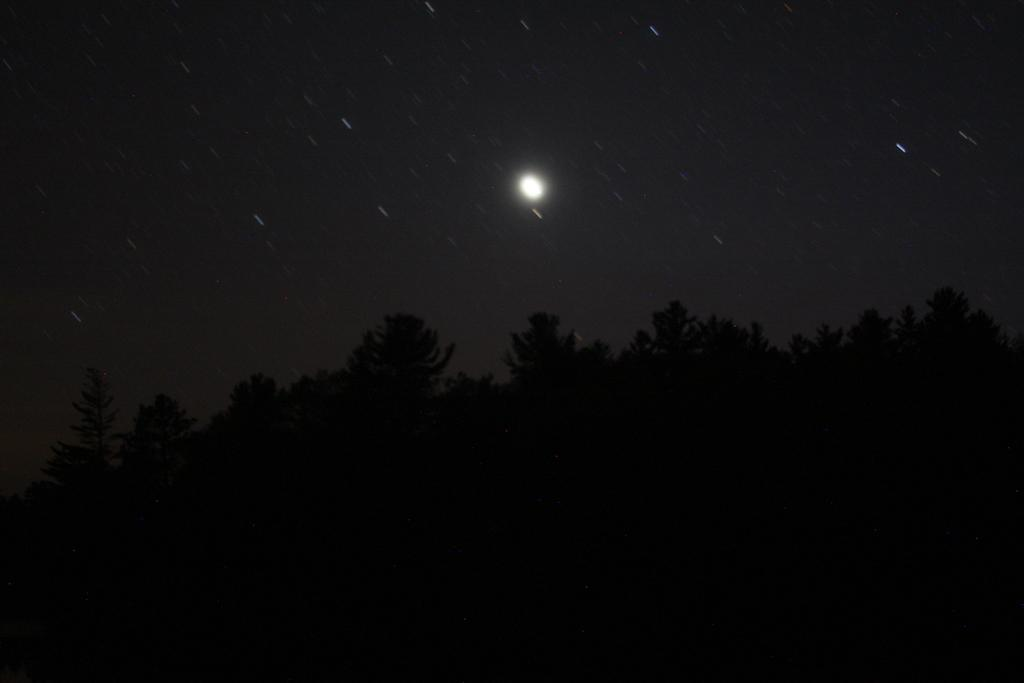What is the primary feature of the image? The primary feature of the image is the presence of many trees. What can be seen in the background of the image? The sky is visible in the background of the image. What type of brick is used to build the property in the image? There is no property or brick present in the image; it primarily features trees and the sky. 